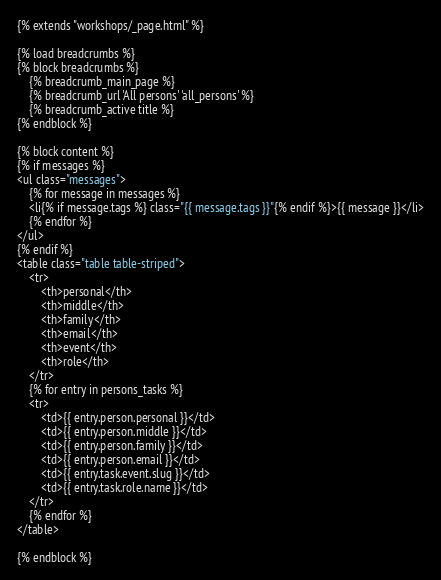<code> <loc_0><loc_0><loc_500><loc_500><_HTML_>{% extends "workshops/_page.html" %}

{% load breadcrumbs %}
{% block breadcrumbs %}
    {% breadcrumb_main_page %}
    {% breadcrumb_url 'All persons' 'all_persons' %}
    {% breadcrumb_active title %}
{% endblock %}

{% block content %}
{% if messages %}
<ul class="messages">
    {% for message in messages %}
    <li{% if message.tags %} class="{{ message.tags }}"{% endif %}>{{ message }}</li>
    {% endfor %}
</ul>
{% endif %}
<table class="table table-striped">
    <tr>
        <th>personal</th>
        <th>middle</th>
        <th>family</th>
        <th>email</th>
        <th>event</th>
        <th>role</th>
    </tr>
    {% for entry in persons_tasks %}
    <tr>
        <td>{{ entry.person.personal }}</td>
        <td>{{ entry.person.middle }}</td>
        <td>{{ entry.person.family }}</td>
        <td>{{ entry.person.email }}</td>
        <td>{{ entry.task.event.slug }}</td>
        <td>{{ entry.task.role.name }}</td>
    </tr>
    {% endfor %}
</table>

{% endblock %}
</code> 